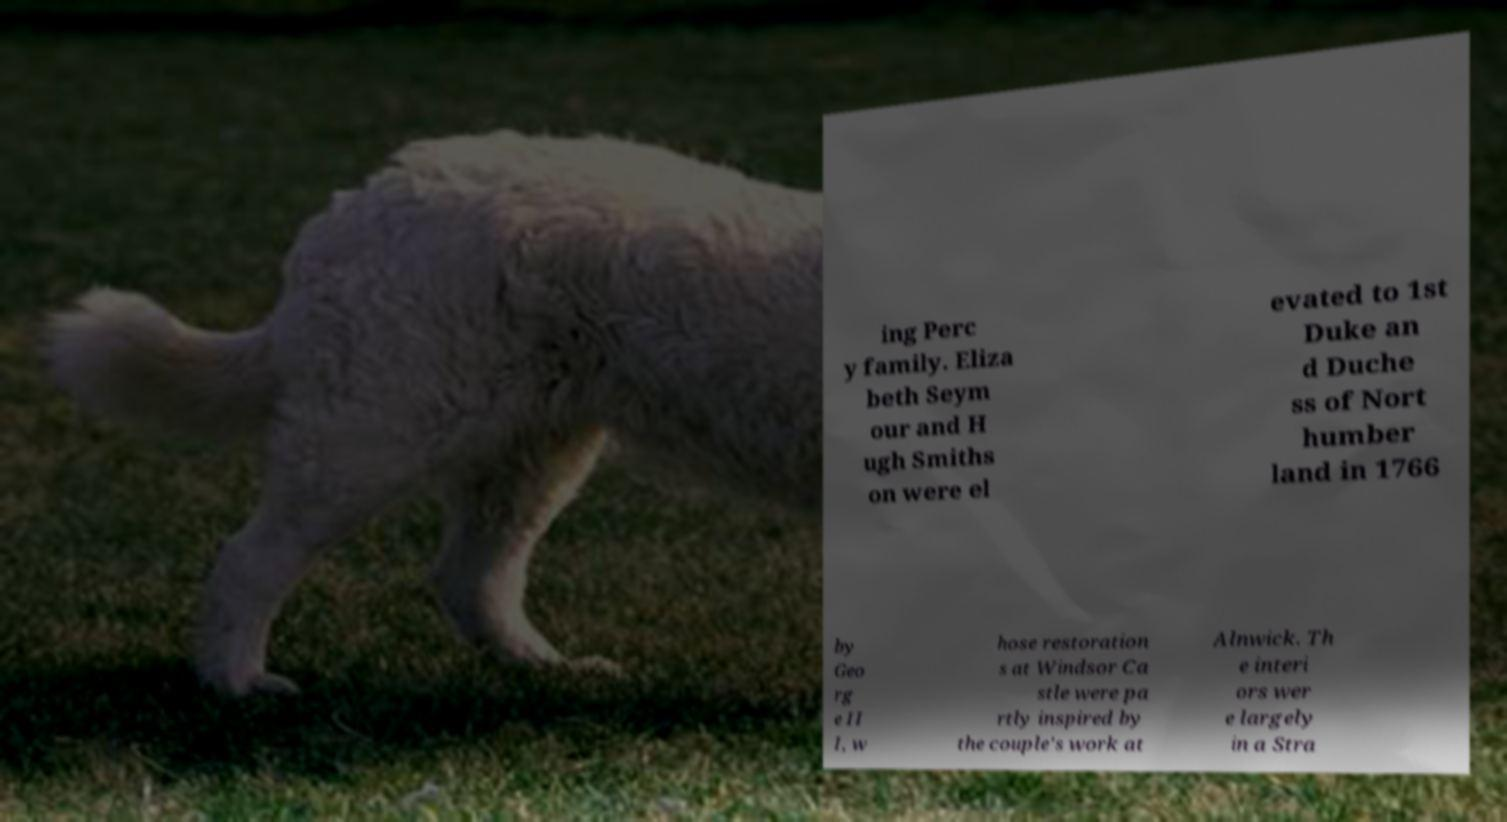What messages or text are displayed in this image? I need them in a readable, typed format. ing Perc y family. Eliza beth Seym our and H ugh Smiths on were el evated to 1st Duke an d Duche ss of Nort humber land in 1766 by Geo rg e II I, w hose restoration s at Windsor Ca stle were pa rtly inspired by the couple's work at Alnwick. Th e interi ors wer e largely in a Stra 